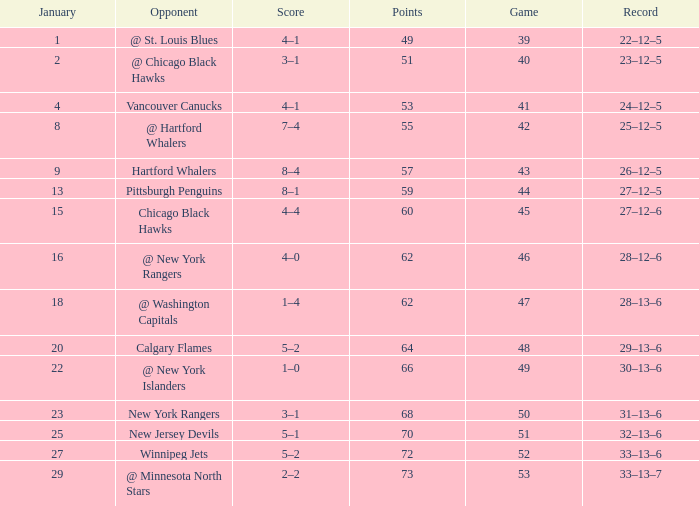Which Points have a Score of 4–1, and a Game smaller than 39? None. 